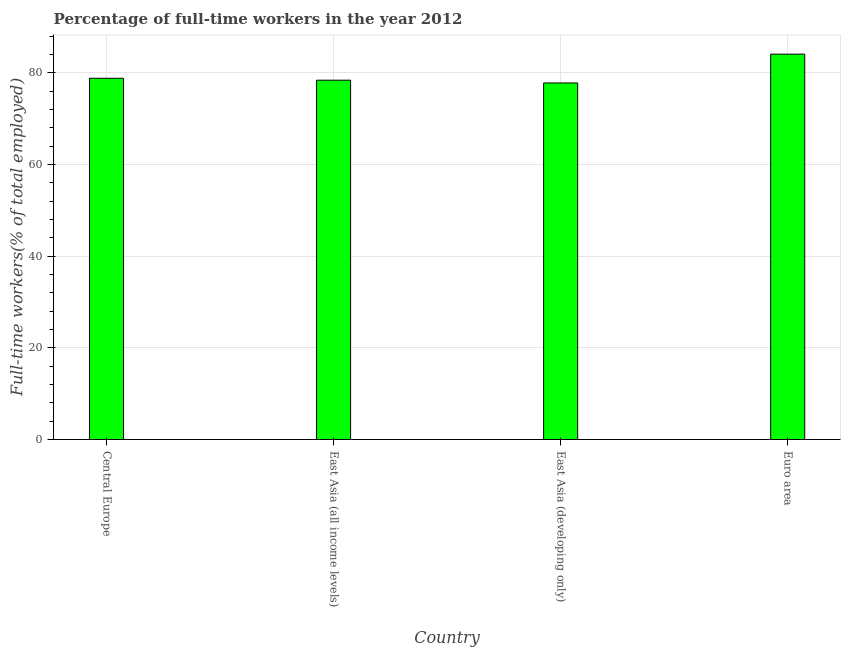Does the graph contain any zero values?
Your response must be concise. No. Does the graph contain grids?
Ensure brevity in your answer.  Yes. What is the title of the graph?
Offer a very short reply. Percentage of full-time workers in the year 2012. What is the label or title of the X-axis?
Provide a succinct answer. Country. What is the label or title of the Y-axis?
Ensure brevity in your answer.  Full-time workers(% of total employed). What is the percentage of full-time workers in Central Europe?
Offer a terse response. 78.84. Across all countries, what is the maximum percentage of full-time workers?
Offer a very short reply. 84.1. Across all countries, what is the minimum percentage of full-time workers?
Your response must be concise. 77.81. In which country was the percentage of full-time workers minimum?
Offer a very short reply. East Asia (developing only). What is the sum of the percentage of full-time workers?
Provide a succinct answer. 319.18. What is the difference between the percentage of full-time workers in Central Europe and Euro area?
Offer a terse response. -5.26. What is the average percentage of full-time workers per country?
Ensure brevity in your answer.  79.79. What is the median percentage of full-time workers?
Make the answer very short. 78.63. What is the ratio of the percentage of full-time workers in East Asia (developing only) to that in Euro area?
Keep it short and to the point. 0.93. Is the percentage of full-time workers in East Asia (all income levels) less than that in East Asia (developing only)?
Your answer should be compact. No. Is the difference between the percentage of full-time workers in Central Europe and East Asia (developing only) greater than the difference between any two countries?
Your answer should be compact. No. What is the difference between the highest and the second highest percentage of full-time workers?
Keep it short and to the point. 5.26. What is the difference between the highest and the lowest percentage of full-time workers?
Give a very brief answer. 6.29. How many bars are there?
Give a very brief answer. 4. How many countries are there in the graph?
Ensure brevity in your answer.  4. What is the Full-time workers(% of total employed) of Central Europe?
Make the answer very short. 78.84. What is the Full-time workers(% of total employed) in East Asia (all income levels)?
Your answer should be very brief. 78.42. What is the Full-time workers(% of total employed) of East Asia (developing only)?
Offer a very short reply. 77.81. What is the Full-time workers(% of total employed) in Euro area?
Offer a very short reply. 84.1. What is the difference between the Full-time workers(% of total employed) in Central Europe and East Asia (all income levels)?
Provide a succinct answer. 0.42. What is the difference between the Full-time workers(% of total employed) in Central Europe and East Asia (developing only)?
Ensure brevity in your answer.  1.03. What is the difference between the Full-time workers(% of total employed) in Central Europe and Euro area?
Make the answer very short. -5.27. What is the difference between the Full-time workers(% of total employed) in East Asia (all income levels) and East Asia (developing only)?
Ensure brevity in your answer.  0.6. What is the difference between the Full-time workers(% of total employed) in East Asia (all income levels) and Euro area?
Your response must be concise. -5.69. What is the difference between the Full-time workers(% of total employed) in East Asia (developing only) and Euro area?
Give a very brief answer. -6.29. What is the ratio of the Full-time workers(% of total employed) in Central Europe to that in East Asia (developing only)?
Offer a very short reply. 1.01. What is the ratio of the Full-time workers(% of total employed) in Central Europe to that in Euro area?
Your answer should be compact. 0.94. What is the ratio of the Full-time workers(% of total employed) in East Asia (all income levels) to that in East Asia (developing only)?
Make the answer very short. 1.01. What is the ratio of the Full-time workers(% of total employed) in East Asia (all income levels) to that in Euro area?
Offer a very short reply. 0.93. What is the ratio of the Full-time workers(% of total employed) in East Asia (developing only) to that in Euro area?
Provide a short and direct response. 0.93. 